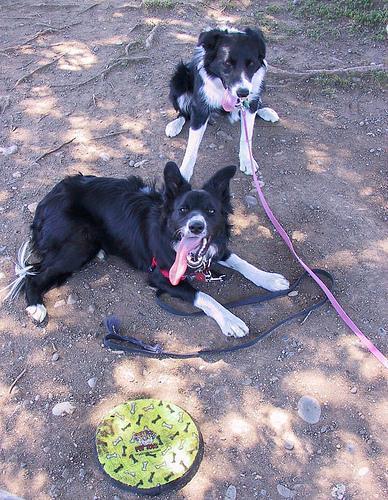How many dogs are there?
Give a very brief answer. 2. 